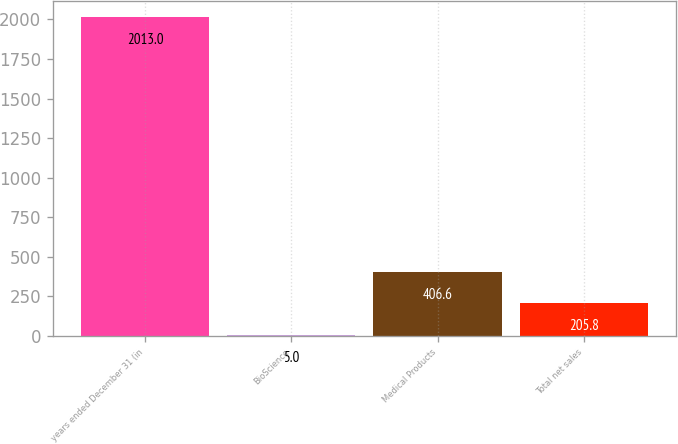Convert chart. <chart><loc_0><loc_0><loc_500><loc_500><bar_chart><fcel>years ended December 31 (in<fcel>BioScience<fcel>Medical Products<fcel>Total net sales<nl><fcel>2013<fcel>5<fcel>406.6<fcel>205.8<nl></chart> 